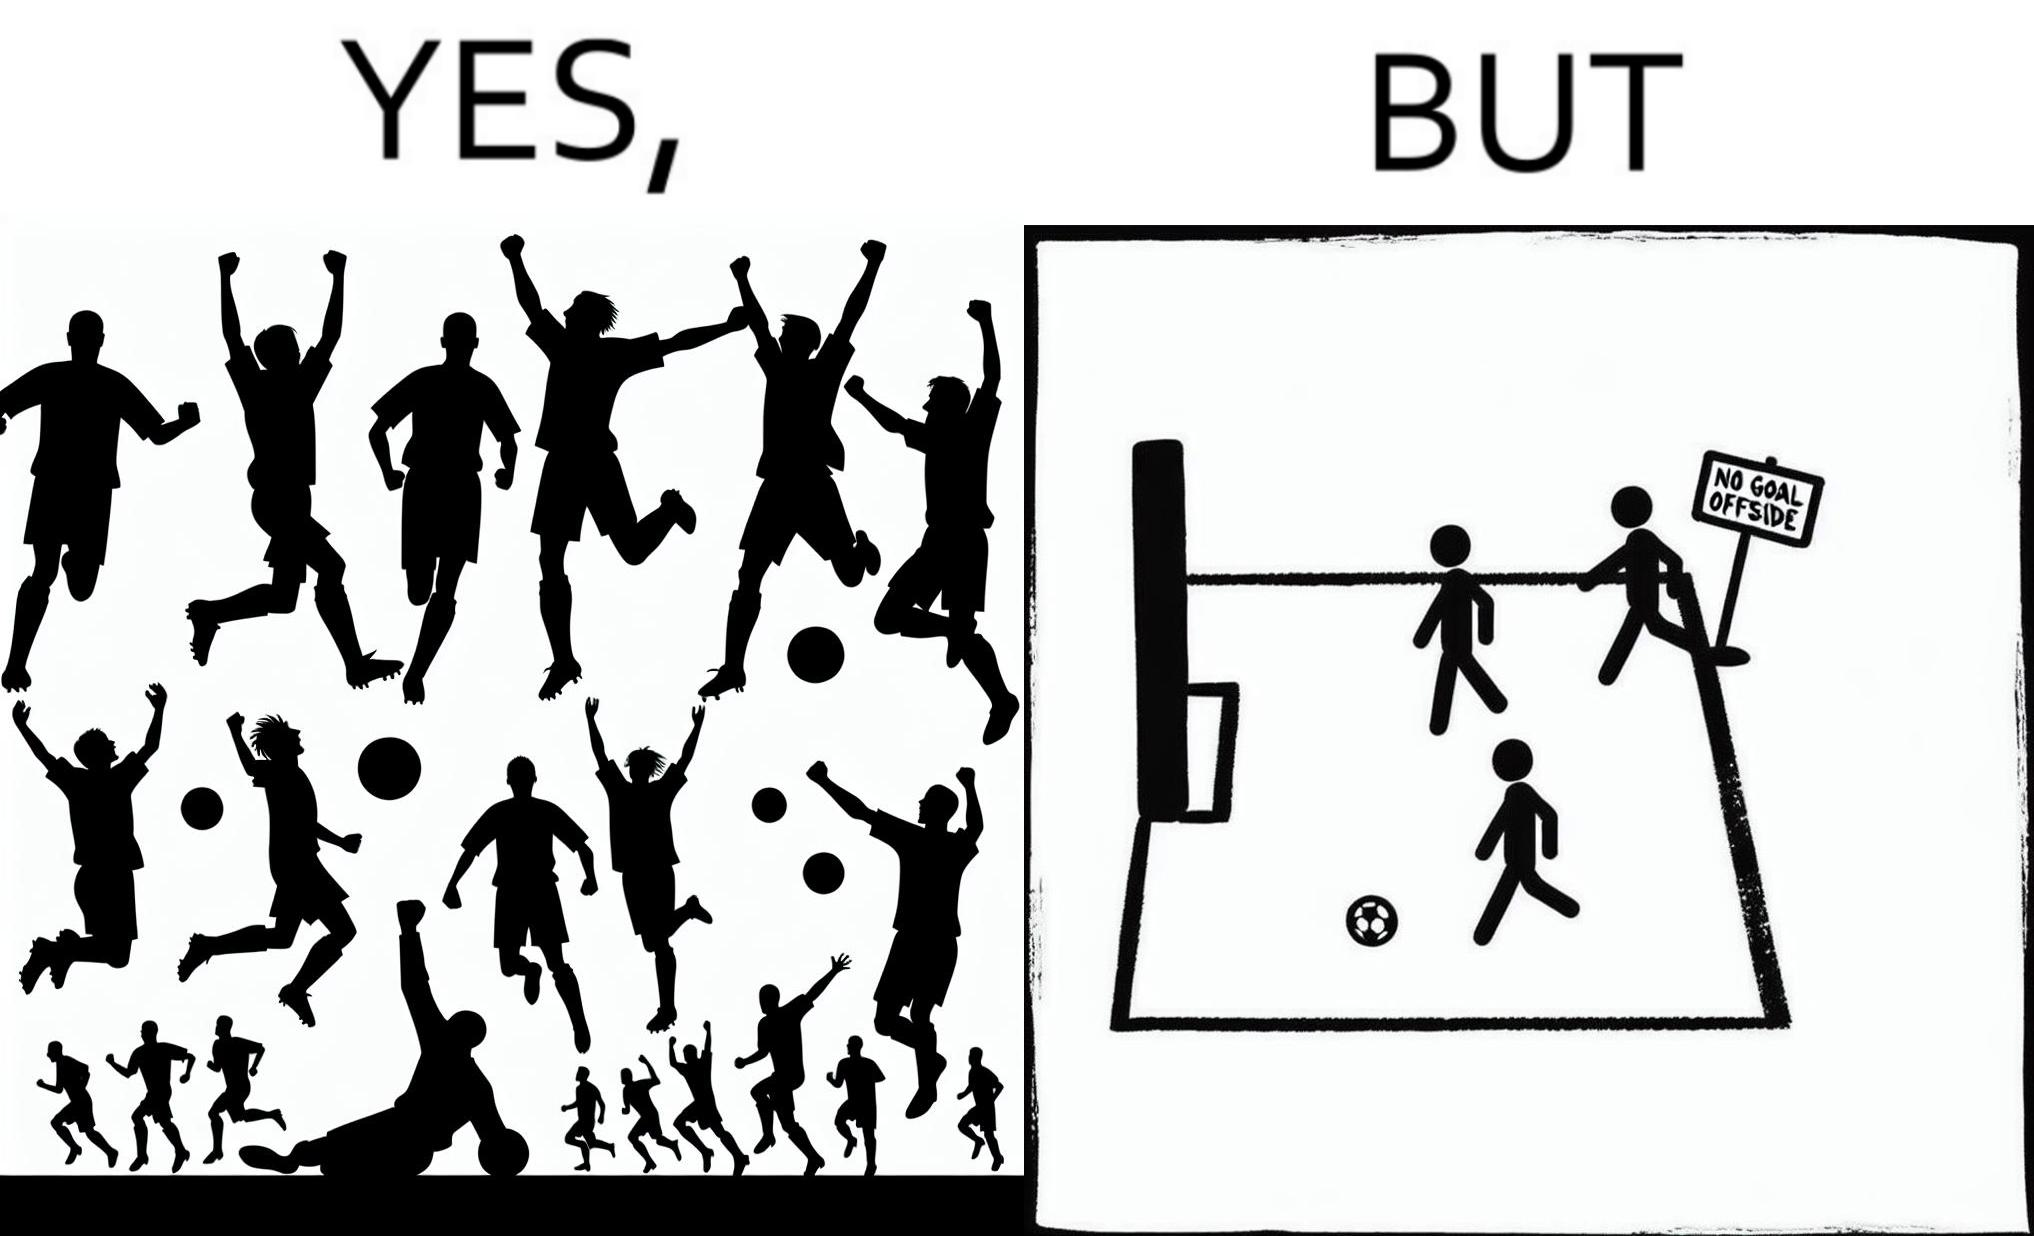What do you see in each half of this image? In the left part of the image: football players celebrating, probably due a goal their team has scored. In the right part of the image: A sign of "No goal - Offside". 